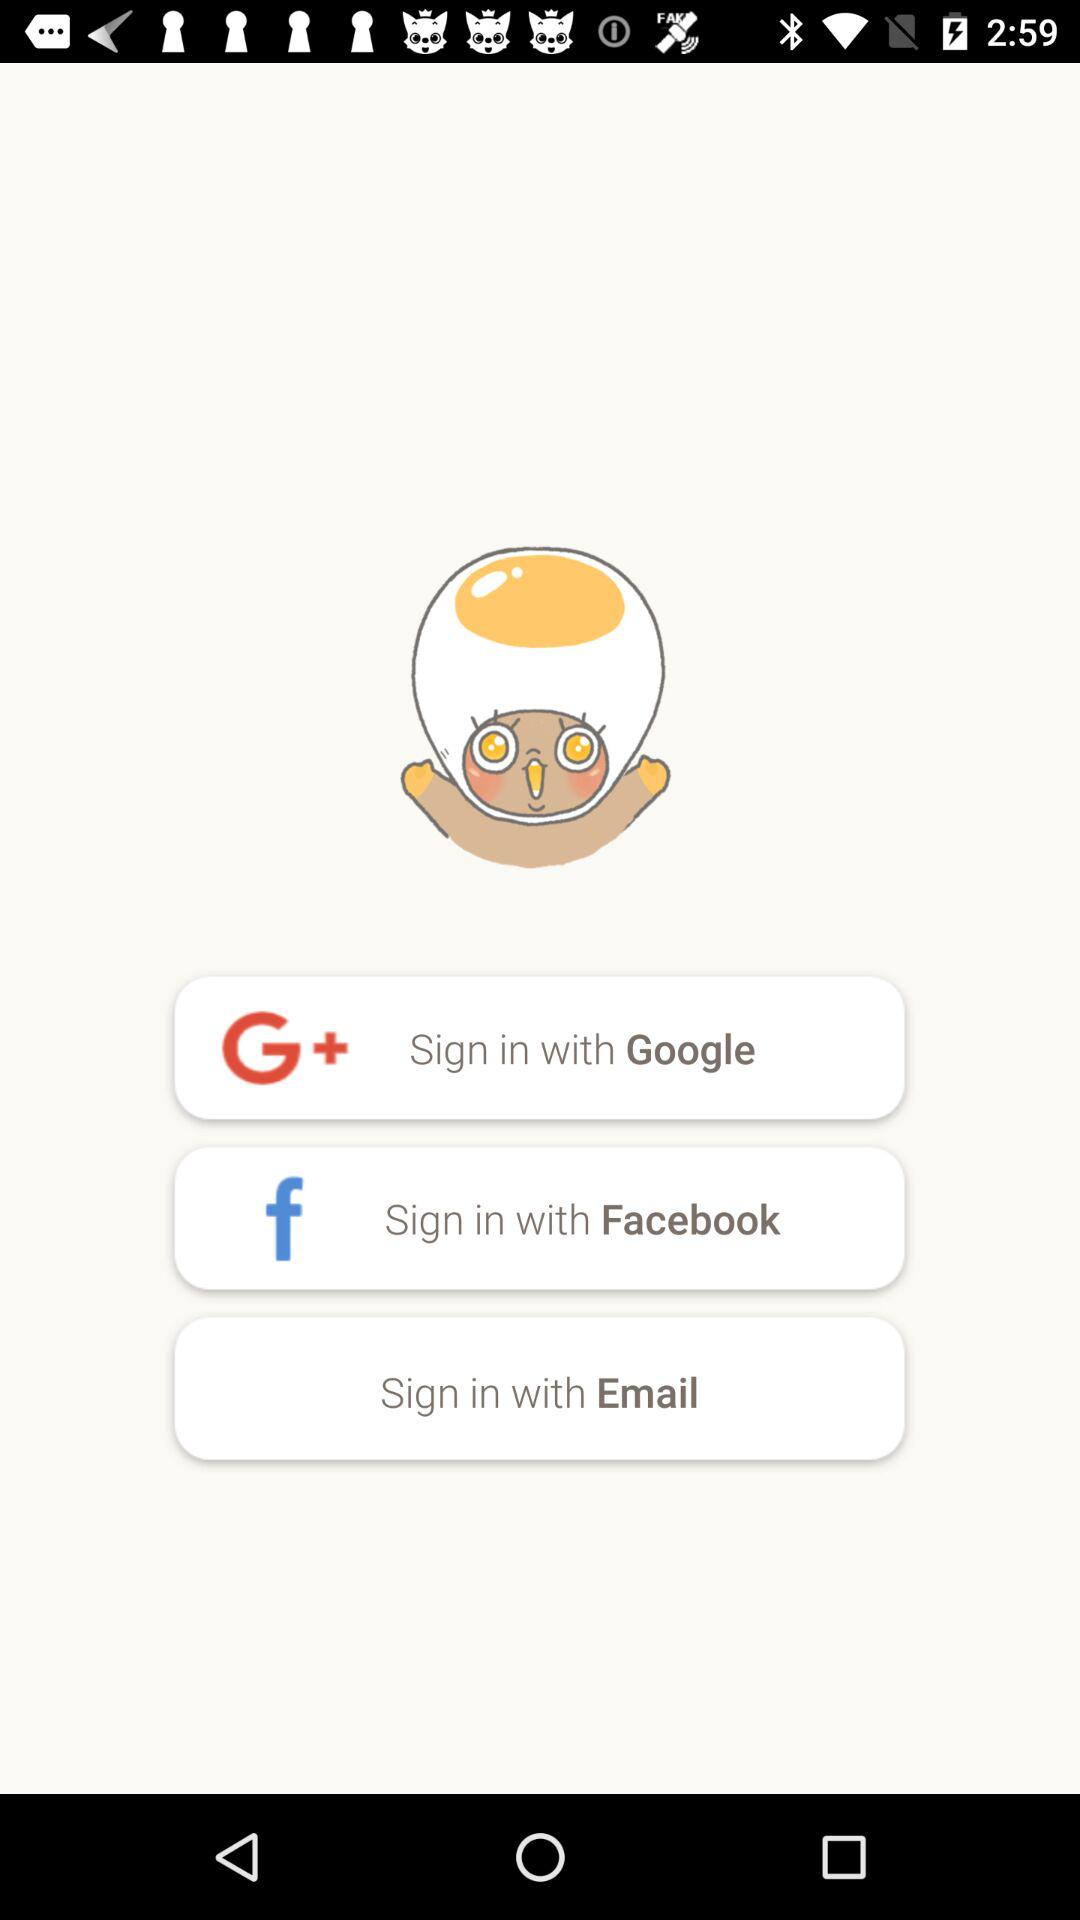Through which application can we sign in? You can sign in with "Google", "Facebook", and "Email". 